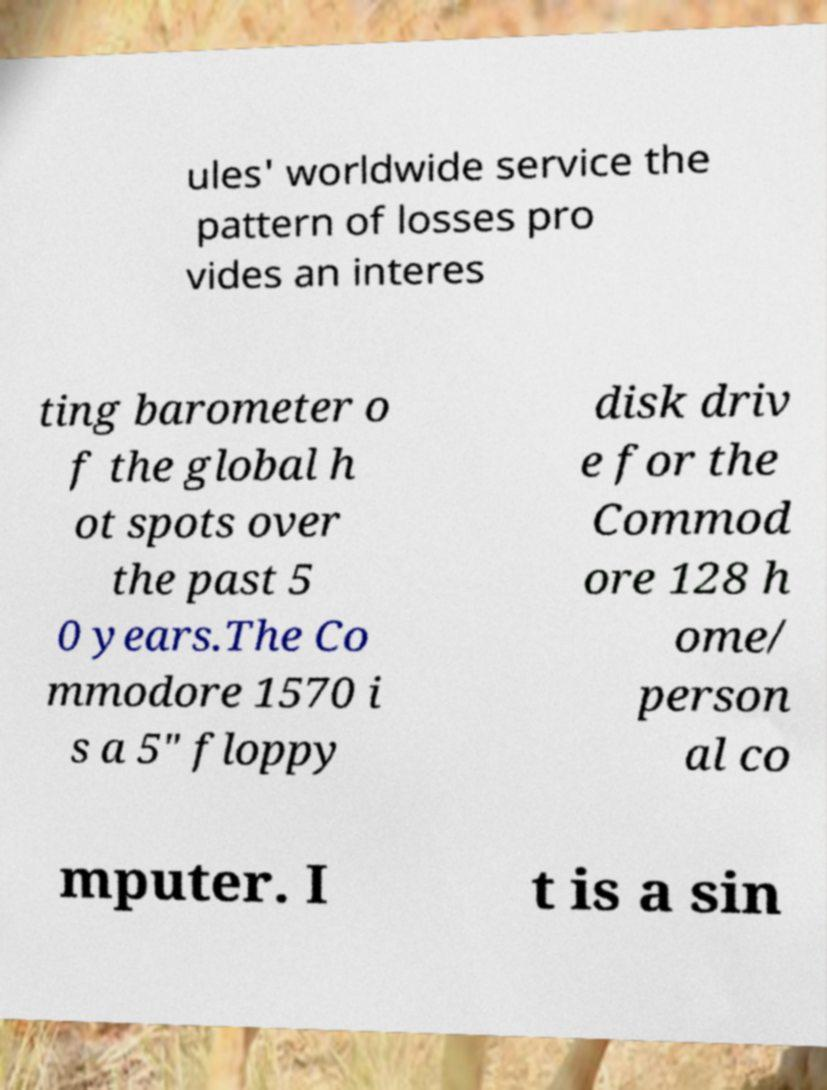Please read and relay the text visible in this image. What does it say? ules' worldwide service the pattern of losses pro vides an interes ting barometer o f the global h ot spots over the past 5 0 years.The Co mmodore 1570 i s a 5" floppy disk driv e for the Commod ore 128 h ome/ person al co mputer. I t is a sin 